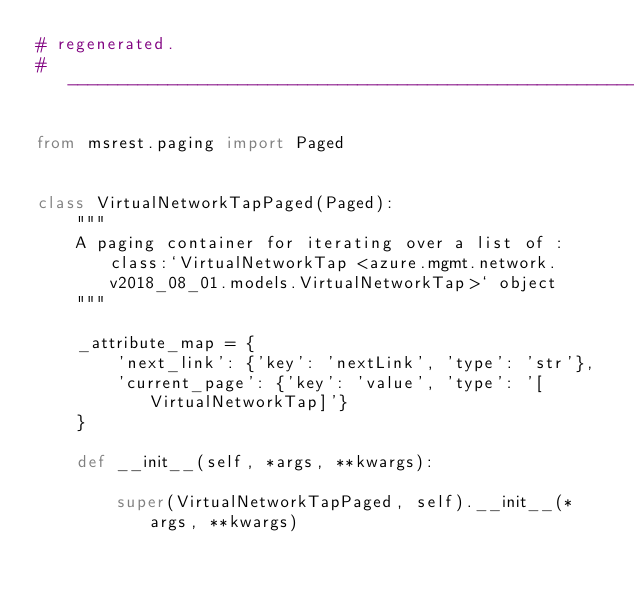<code> <loc_0><loc_0><loc_500><loc_500><_Python_># regenerated.
# --------------------------------------------------------------------------

from msrest.paging import Paged


class VirtualNetworkTapPaged(Paged):
    """
    A paging container for iterating over a list of :class:`VirtualNetworkTap <azure.mgmt.network.v2018_08_01.models.VirtualNetworkTap>` object
    """

    _attribute_map = {
        'next_link': {'key': 'nextLink', 'type': 'str'},
        'current_page': {'key': 'value', 'type': '[VirtualNetworkTap]'}
    }

    def __init__(self, *args, **kwargs):

        super(VirtualNetworkTapPaged, self).__init__(*args, **kwargs)
</code> 